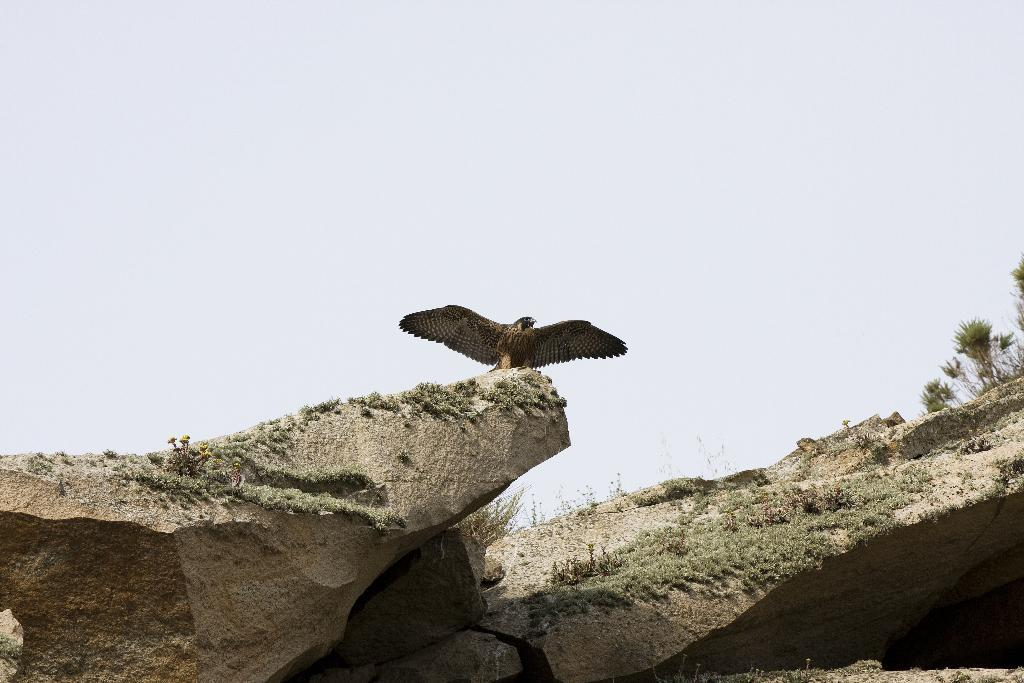What is the main subject of the image? The main subject of the image is a bird standing on a stone. What is the bird standing on? The bird is standing on a stone in the image. What type of vegetation is present on the stones? There is grass on the stones in the image. What can be seen on the right side of the image? There are trees on the right side of the image. What color is the manager's vest in the image? There is no manager or vest present in the image. How does the balloon affect the bird's behavior in the image? There is no balloon present in the image, so it does not affect the bird's behavior. 